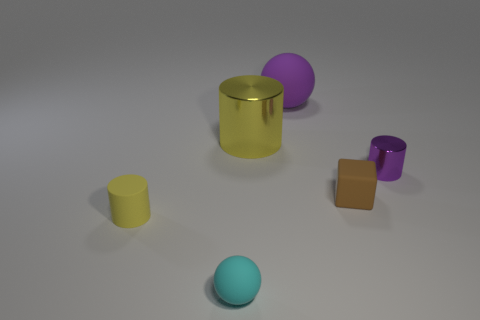How would you describe the lighting and the colors used in this composition? The lighting in this image appears to be soft and diffused, casting gentle shadows and providing a clear view of each object. As for the colors, they are solid and vivid, with each object featuring a different hue — cyan, yellow, gold, purple, and orange — which creates a visually engaging array of colors. The colors chosen have a matte finish except for the gold cylinder, which has a reflective surface that stands out in this arrangement. 